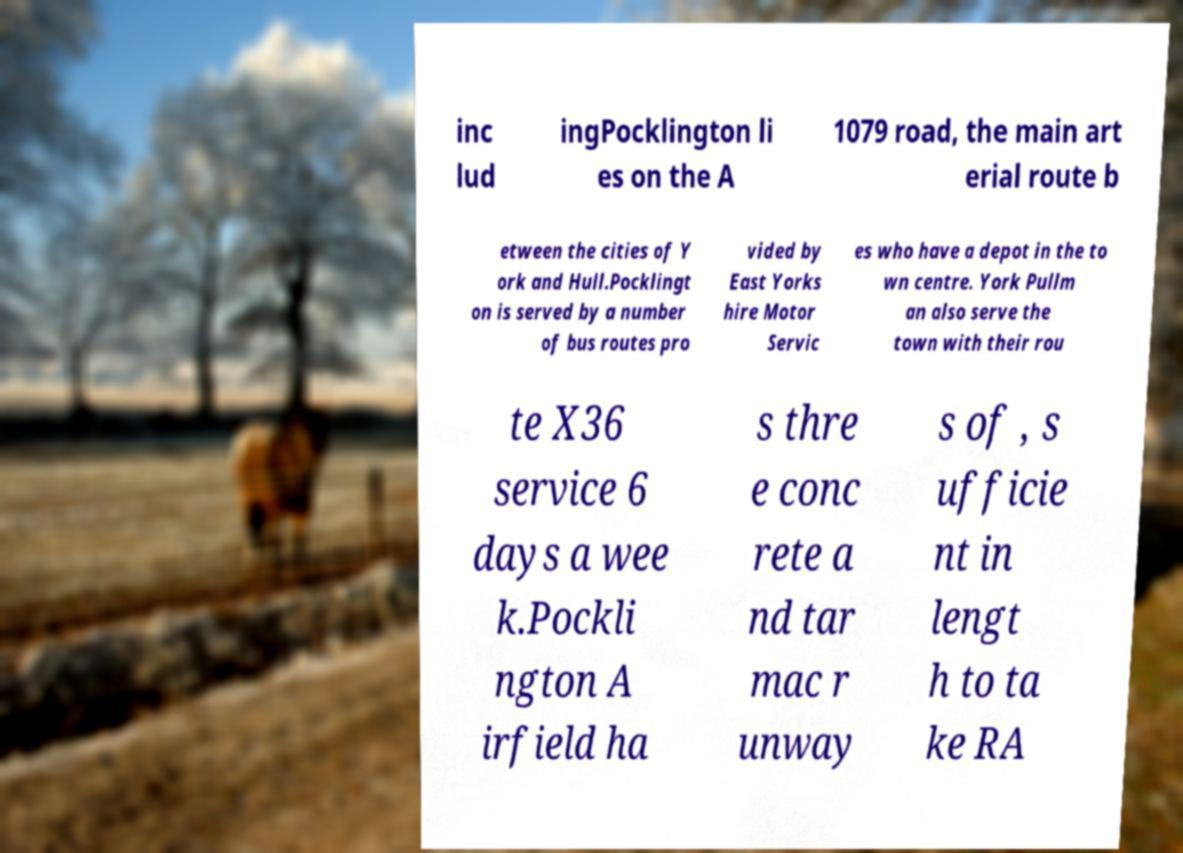Could you extract and type out the text from this image? inc lud ingPocklington li es on the A 1079 road, the main art erial route b etween the cities of Y ork and Hull.Pocklingt on is served by a number of bus routes pro vided by East Yorks hire Motor Servic es who have a depot in the to wn centre. York Pullm an also serve the town with their rou te X36 service 6 days a wee k.Pockli ngton A irfield ha s thre e conc rete a nd tar mac r unway s of , s ufficie nt in lengt h to ta ke RA 